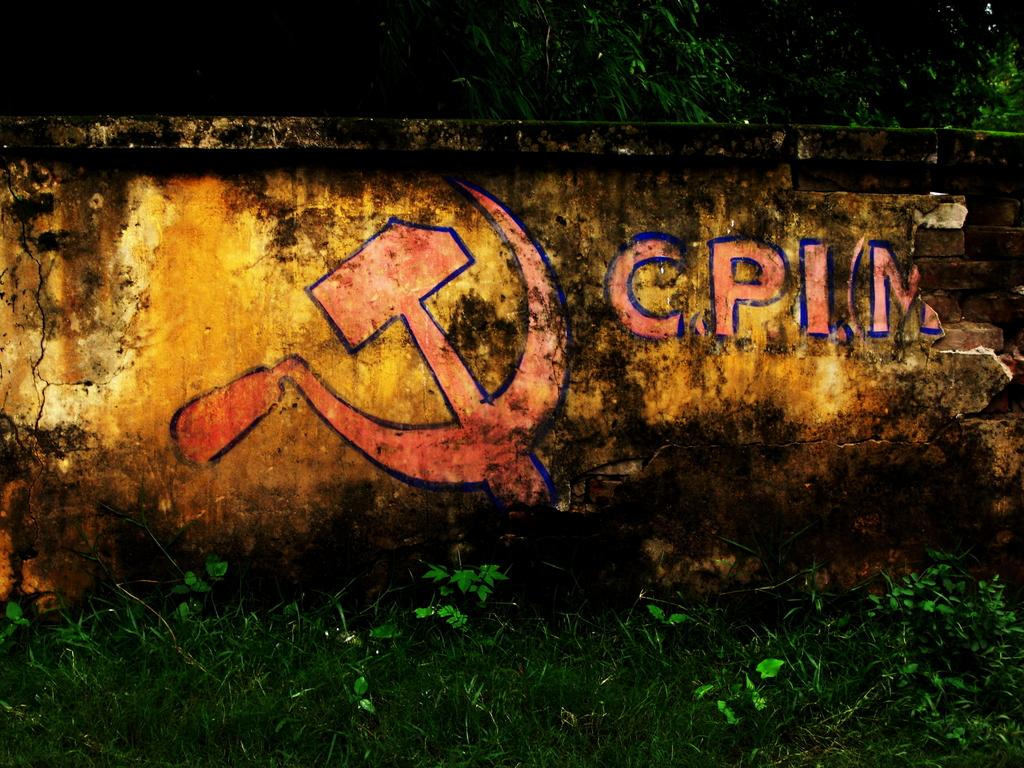What is hanging on the wall in the image? There is a painting on the wall in the image. What type of vegetation can be seen in the image? There are plants, grass, and trees visible in the image. Can you describe the background of the image? The background of the image includes trees. Where is the faucet located in the image? There is no faucet present in the image. What type of experience can be gained from the painting in the image? The image does not convey any specific experience; it is a still image of a painting on a wall. 